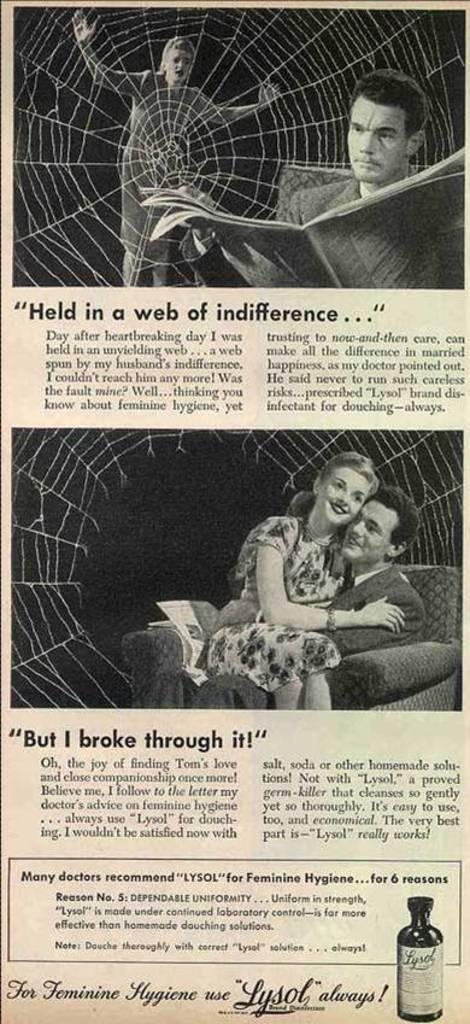How many images are present in the picture? There are two images in the picture. What is located below the images? There is text written below the images. What type of wire is used to hold the mint and berry in the image? There is no wire, mint, or berry present in the image. 